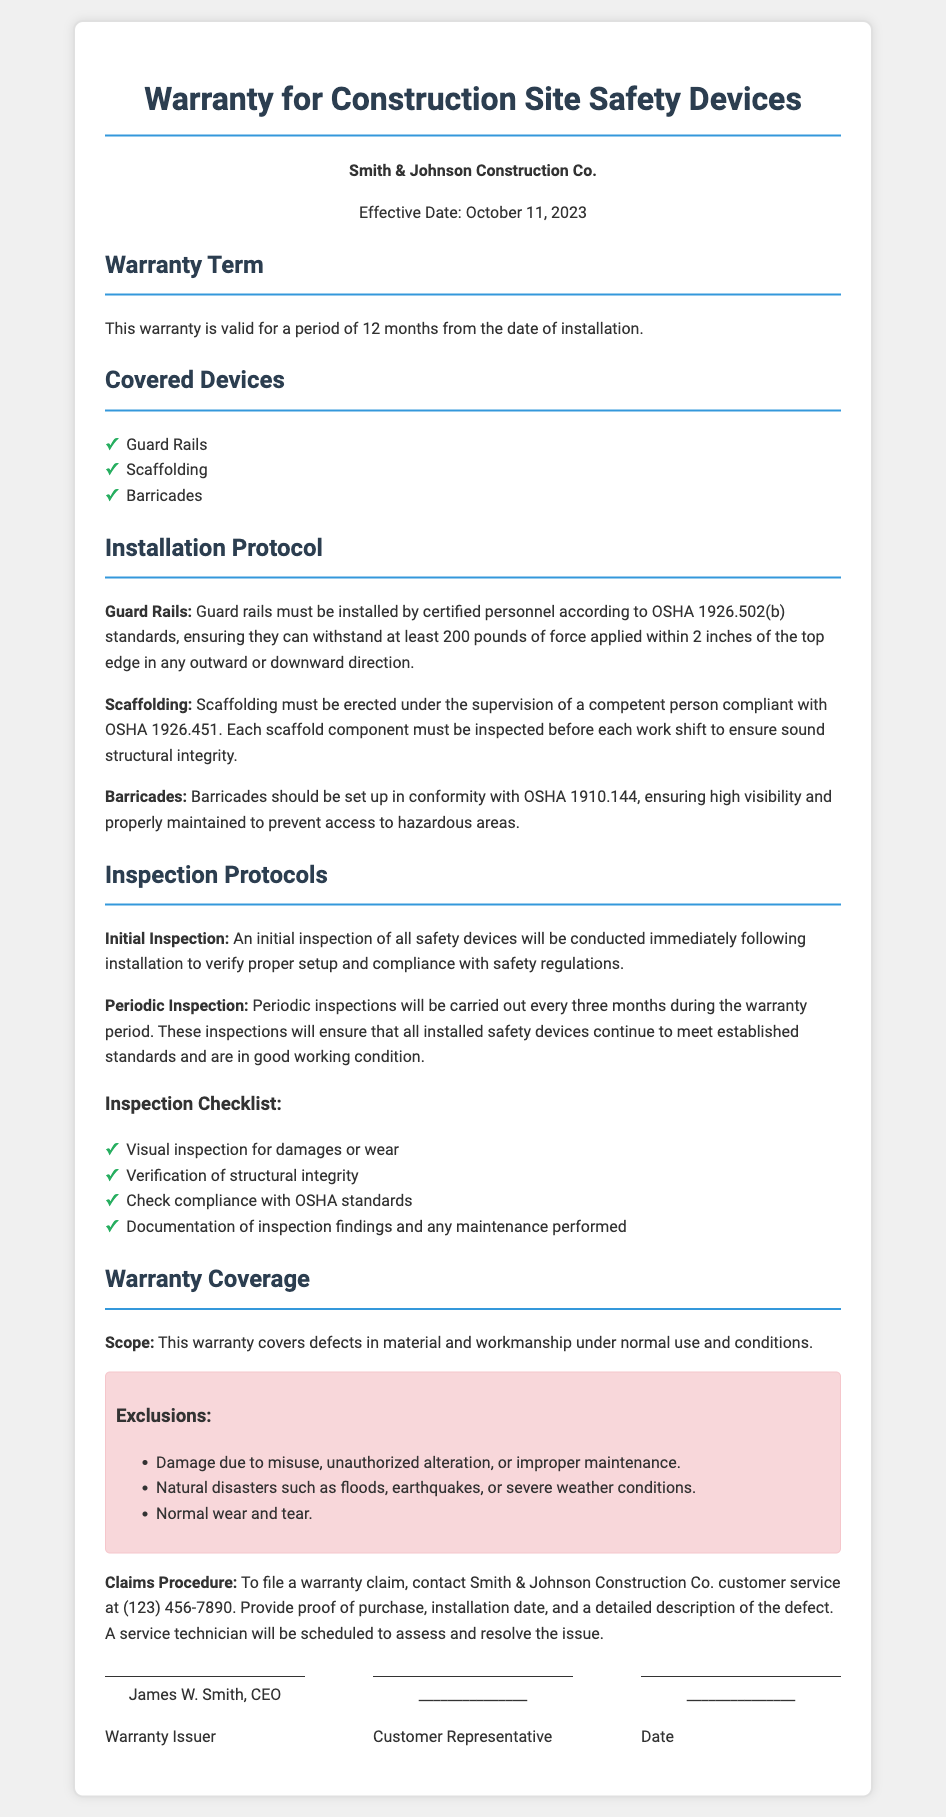what is the effective date of the warranty? The effective date of the warranty is stated at the beginning of the document.
Answer: October 11, 2023 how long is the warranty term? The warranty term is mentioned in a dedicated section of the document.
Answer: 12 months which company issues the warranty? The company name is prominently displayed in the company info section of the document.
Answer: Smith & Johnson Construction Co what is the inspection frequency during the warranty period? The frequency of inspections is discussed in the inspection protocols section.
Answer: every three months what type of damage is excluded from warranty coverage? The exclusions section lists various types of damage that are not covered.
Answer: misuse who is responsible for installing the guard rails? The installation protocol specifies who should install the guard rails.
Answer: certified personnel what standard must scaffolding comply with? The installation protocol for scaffolding references a specific OSHA standard.
Answer: OSHA 1926.451 how can a warranty claim be filed? The claims procedure section outlines the steps required to file a warranty claim.
Answer: contact customer service what must be verified in the periodic inspection? The inspection list outlines the tasks to be completed during the inspection.
Answer: compliance with OSHA standards 